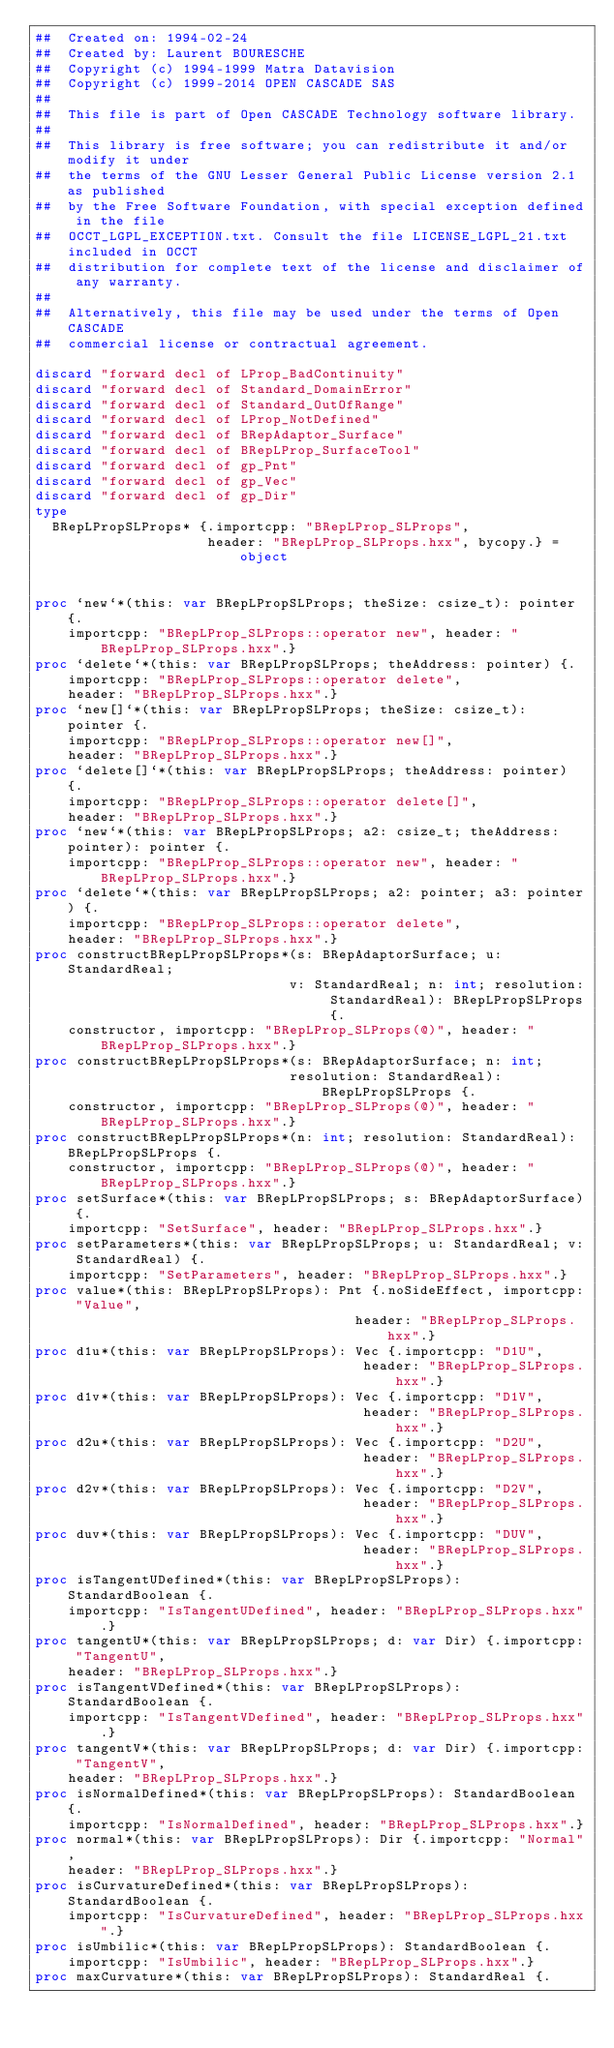Convert code to text. <code><loc_0><loc_0><loc_500><loc_500><_Nim_>##  Created on: 1994-02-24
##  Created by: Laurent BOURESCHE
##  Copyright (c) 1994-1999 Matra Datavision
##  Copyright (c) 1999-2014 OPEN CASCADE SAS
##
##  This file is part of Open CASCADE Technology software library.
##
##  This library is free software; you can redistribute it and/or modify it under
##  the terms of the GNU Lesser General Public License version 2.1 as published
##  by the Free Software Foundation, with special exception defined in the file
##  OCCT_LGPL_EXCEPTION.txt. Consult the file LICENSE_LGPL_21.txt included in OCCT
##  distribution for complete text of the license and disclaimer of any warranty.
##
##  Alternatively, this file may be used under the terms of Open CASCADE
##  commercial license or contractual agreement.

discard "forward decl of LProp_BadContinuity"
discard "forward decl of Standard_DomainError"
discard "forward decl of Standard_OutOfRange"
discard "forward decl of LProp_NotDefined"
discard "forward decl of BRepAdaptor_Surface"
discard "forward decl of BRepLProp_SurfaceTool"
discard "forward decl of gp_Pnt"
discard "forward decl of gp_Vec"
discard "forward decl of gp_Dir"
type
  BRepLPropSLProps* {.importcpp: "BRepLProp_SLProps",
                     header: "BRepLProp_SLProps.hxx", bycopy.} = object


proc `new`*(this: var BRepLPropSLProps; theSize: csize_t): pointer {.
    importcpp: "BRepLProp_SLProps::operator new", header: "BRepLProp_SLProps.hxx".}
proc `delete`*(this: var BRepLPropSLProps; theAddress: pointer) {.
    importcpp: "BRepLProp_SLProps::operator delete",
    header: "BRepLProp_SLProps.hxx".}
proc `new[]`*(this: var BRepLPropSLProps; theSize: csize_t): pointer {.
    importcpp: "BRepLProp_SLProps::operator new[]",
    header: "BRepLProp_SLProps.hxx".}
proc `delete[]`*(this: var BRepLPropSLProps; theAddress: pointer) {.
    importcpp: "BRepLProp_SLProps::operator delete[]",
    header: "BRepLProp_SLProps.hxx".}
proc `new`*(this: var BRepLPropSLProps; a2: csize_t; theAddress: pointer): pointer {.
    importcpp: "BRepLProp_SLProps::operator new", header: "BRepLProp_SLProps.hxx".}
proc `delete`*(this: var BRepLPropSLProps; a2: pointer; a3: pointer) {.
    importcpp: "BRepLProp_SLProps::operator delete",
    header: "BRepLProp_SLProps.hxx".}
proc constructBRepLPropSLProps*(s: BRepAdaptorSurface; u: StandardReal;
                               v: StandardReal; n: int; resolution: StandardReal): BRepLPropSLProps {.
    constructor, importcpp: "BRepLProp_SLProps(@)", header: "BRepLProp_SLProps.hxx".}
proc constructBRepLPropSLProps*(s: BRepAdaptorSurface; n: int;
                               resolution: StandardReal): BRepLPropSLProps {.
    constructor, importcpp: "BRepLProp_SLProps(@)", header: "BRepLProp_SLProps.hxx".}
proc constructBRepLPropSLProps*(n: int; resolution: StandardReal): BRepLPropSLProps {.
    constructor, importcpp: "BRepLProp_SLProps(@)", header: "BRepLProp_SLProps.hxx".}
proc setSurface*(this: var BRepLPropSLProps; s: BRepAdaptorSurface) {.
    importcpp: "SetSurface", header: "BRepLProp_SLProps.hxx".}
proc setParameters*(this: var BRepLPropSLProps; u: StandardReal; v: StandardReal) {.
    importcpp: "SetParameters", header: "BRepLProp_SLProps.hxx".}
proc value*(this: BRepLPropSLProps): Pnt {.noSideEffect, importcpp: "Value",
                                       header: "BRepLProp_SLProps.hxx".}
proc d1u*(this: var BRepLPropSLProps): Vec {.importcpp: "D1U",
                                        header: "BRepLProp_SLProps.hxx".}
proc d1v*(this: var BRepLPropSLProps): Vec {.importcpp: "D1V",
                                        header: "BRepLProp_SLProps.hxx".}
proc d2u*(this: var BRepLPropSLProps): Vec {.importcpp: "D2U",
                                        header: "BRepLProp_SLProps.hxx".}
proc d2v*(this: var BRepLPropSLProps): Vec {.importcpp: "D2V",
                                        header: "BRepLProp_SLProps.hxx".}
proc duv*(this: var BRepLPropSLProps): Vec {.importcpp: "DUV",
                                        header: "BRepLProp_SLProps.hxx".}
proc isTangentUDefined*(this: var BRepLPropSLProps): StandardBoolean {.
    importcpp: "IsTangentUDefined", header: "BRepLProp_SLProps.hxx".}
proc tangentU*(this: var BRepLPropSLProps; d: var Dir) {.importcpp: "TangentU",
    header: "BRepLProp_SLProps.hxx".}
proc isTangentVDefined*(this: var BRepLPropSLProps): StandardBoolean {.
    importcpp: "IsTangentVDefined", header: "BRepLProp_SLProps.hxx".}
proc tangentV*(this: var BRepLPropSLProps; d: var Dir) {.importcpp: "TangentV",
    header: "BRepLProp_SLProps.hxx".}
proc isNormalDefined*(this: var BRepLPropSLProps): StandardBoolean {.
    importcpp: "IsNormalDefined", header: "BRepLProp_SLProps.hxx".}
proc normal*(this: var BRepLPropSLProps): Dir {.importcpp: "Normal",
    header: "BRepLProp_SLProps.hxx".}
proc isCurvatureDefined*(this: var BRepLPropSLProps): StandardBoolean {.
    importcpp: "IsCurvatureDefined", header: "BRepLProp_SLProps.hxx".}
proc isUmbilic*(this: var BRepLPropSLProps): StandardBoolean {.
    importcpp: "IsUmbilic", header: "BRepLProp_SLProps.hxx".}
proc maxCurvature*(this: var BRepLPropSLProps): StandardReal {.</code> 